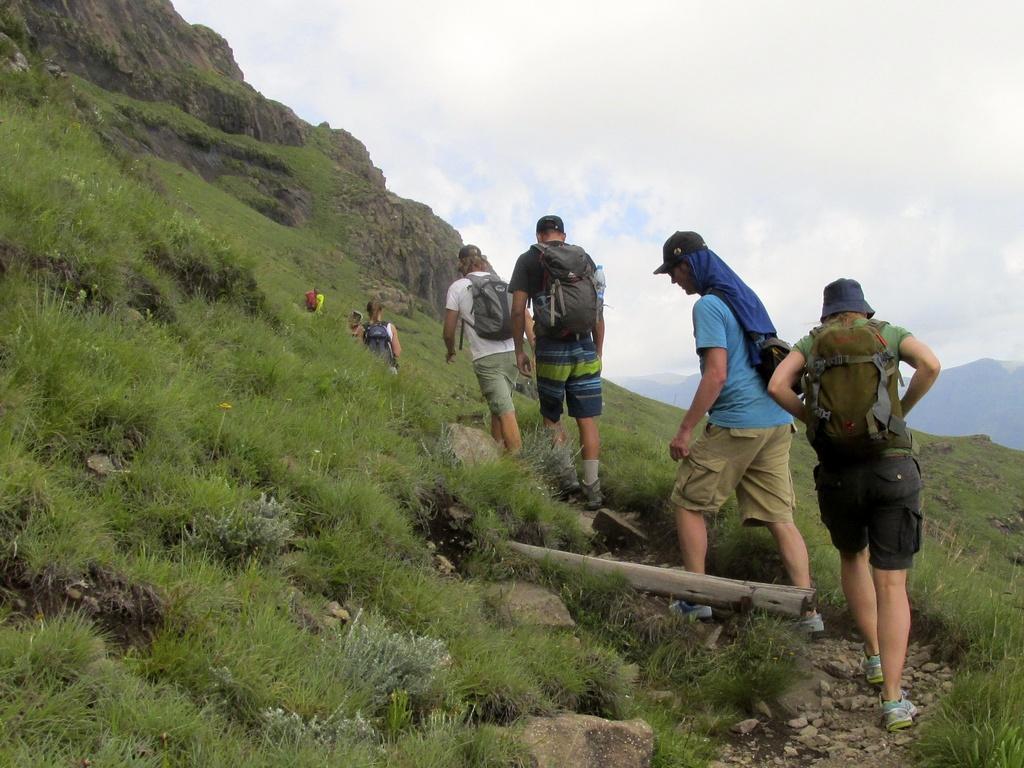Describe this image in one or two sentences. In the center of the image there are people. At the bottom of the image there is grass on the surface. There are rocks. In the background of the image there are mountains and sky. 